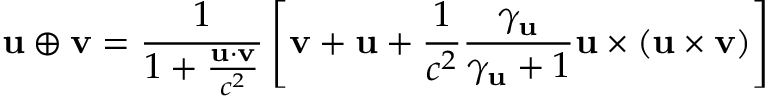Convert formula to latex. <formula><loc_0><loc_0><loc_500><loc_500>u \oplus v = { \frac { 1 } { 1 + { \frac { u \cdot v } { c ^ { 2 } } } } } \left [ v + u + { \frac { 1 } { c ^ { 2 } } } { \frac { \gamma _ { u } } { \gamma _ { u } + 1 } } u \times ( u \times v ) \right ]</formula> 